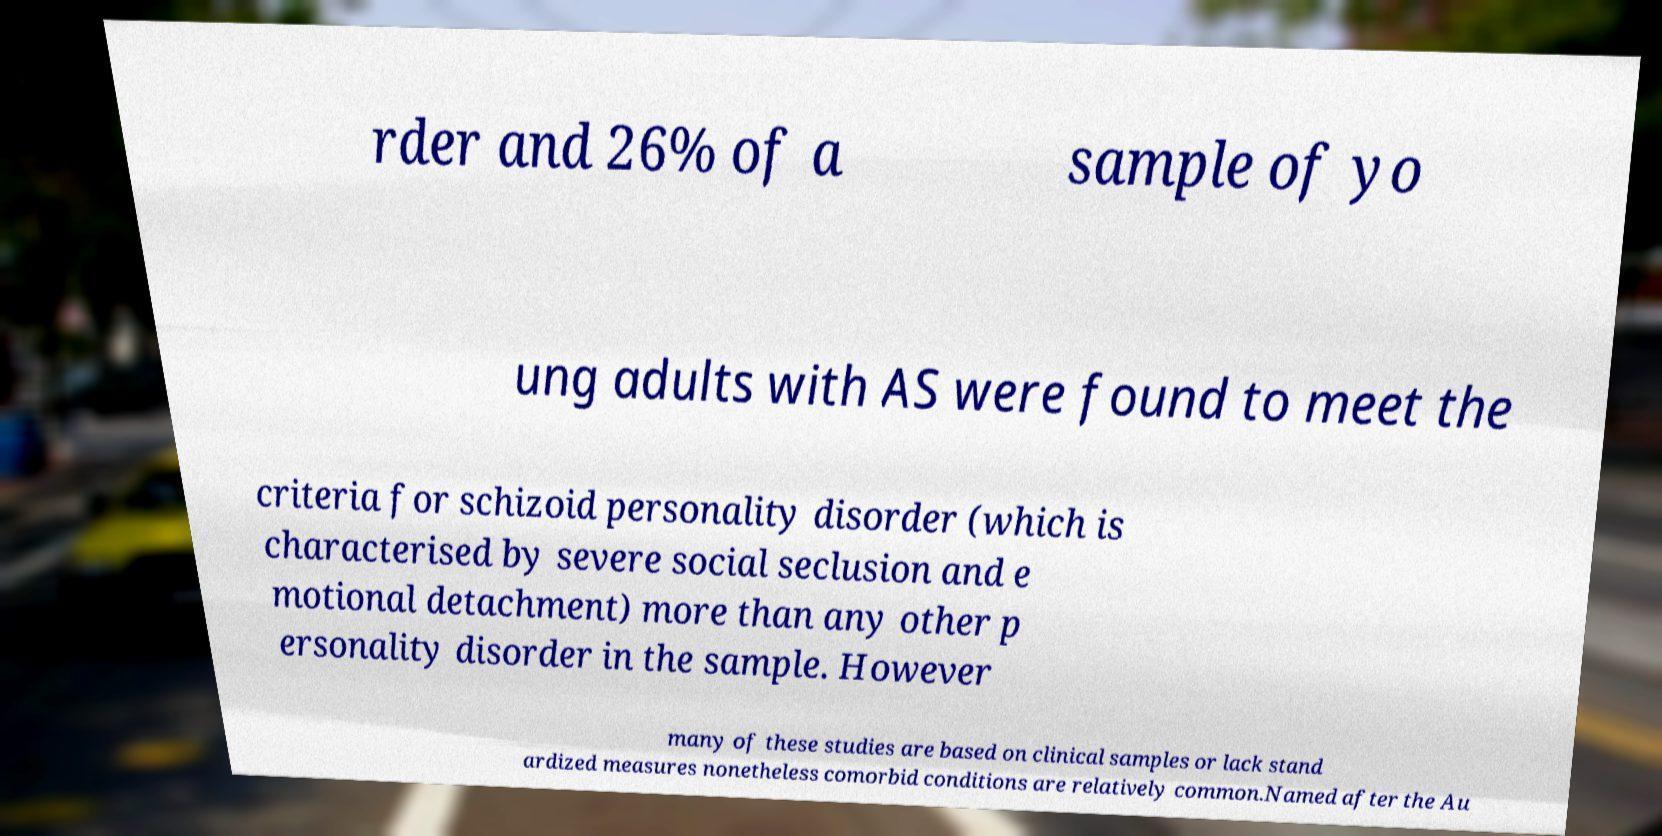Can you accurately transcribe the text from the provided image for me? rder and 26% of a sample of yo ung adults with AS were found to meet the criteria for schizoid personality disorder (which is characterised by severe social seclusion and e motional detachment) more than any other p ersonality disorder in the sample. However many of these studies are based on clinical samples or lack stand ardized measures nonetheless comorbid conditions are relatively common.Named after the Au 